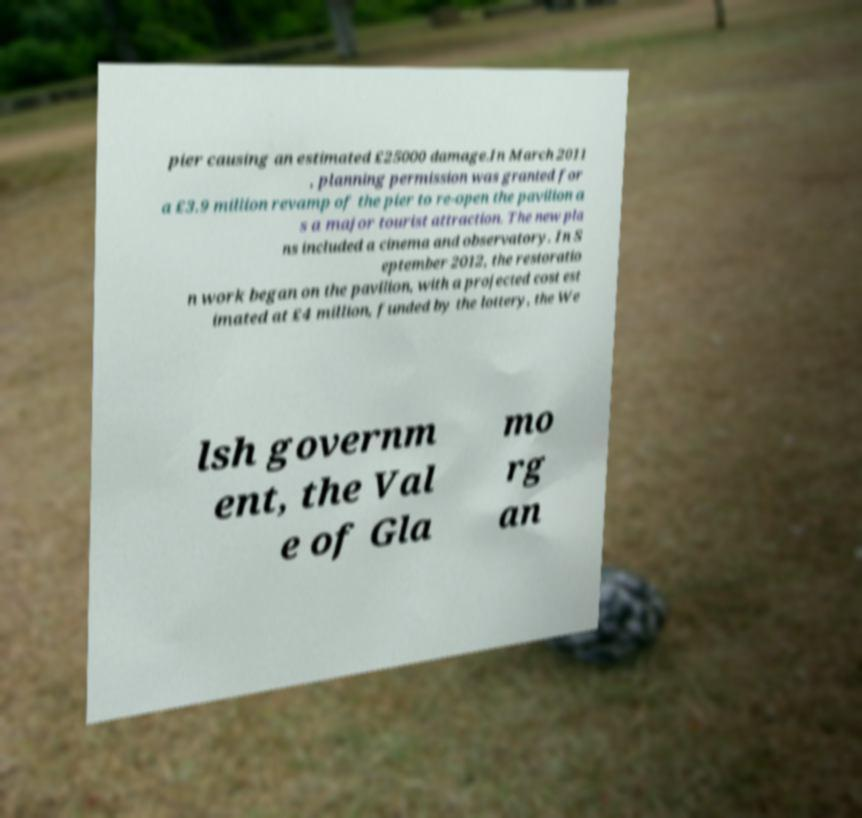Please read and relay the text visible in this image. What does it say? pier causing an estimated £25000 damage.In March 2011 , planning permission was granted for a £3.9 million revamp of the pier to re-open the pavilion a s a major tourist attraction. The new pla ns included a cinema and observatory. In S eptember 2012, the restoratio n work began on the pavilion, with a projected cost est imated at £4 million, funded by the lottery, the We lsh governm ent, the Val e of Gla mo rg an 